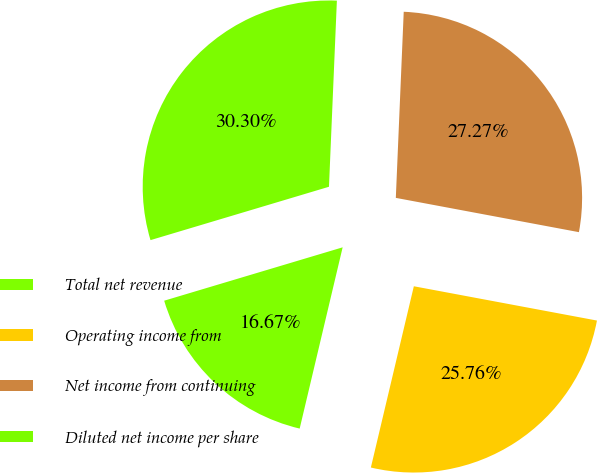Convert chart to OTSL. <chart><loc_0><loc_0><loc_500><loc_500><pie_chart><fcel>Total net revenue<fcel>Operating income from<fcel>Net income from continuing<fcel>Diluted net income per share<nl><fcel>16.67%<fcel>25.76%<fcel>27.27%<fcel>30.3%<nl></chart> 